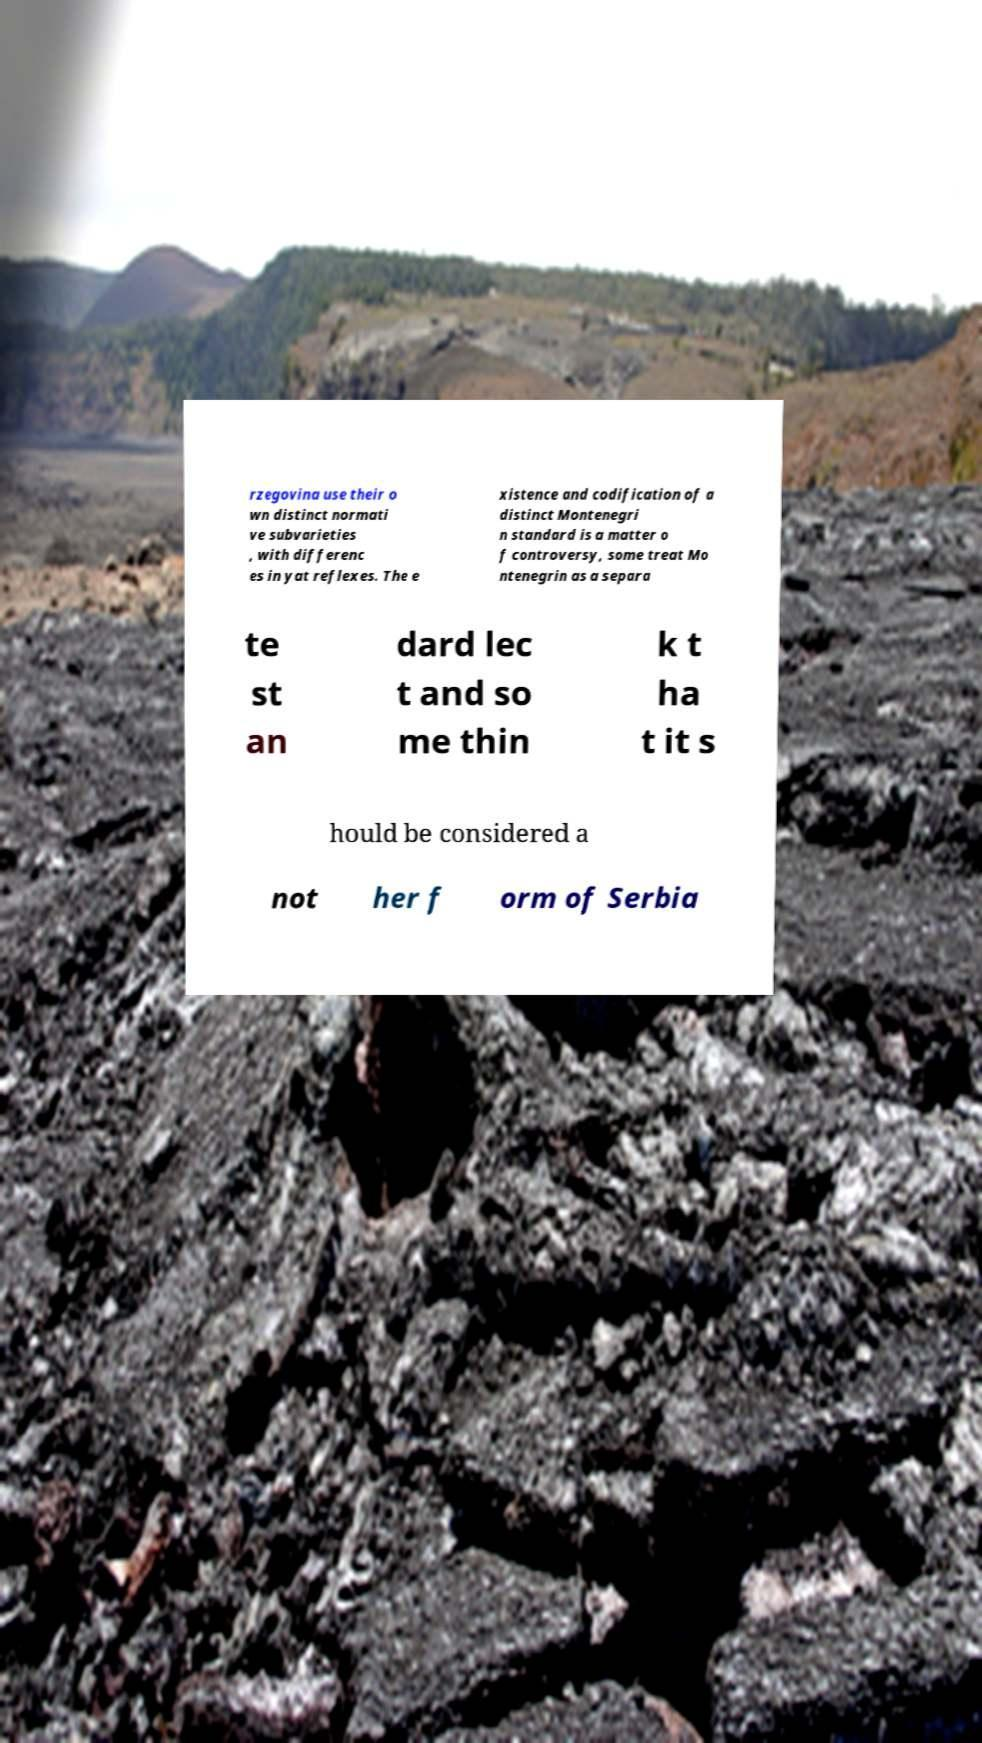Can you read and provide the text displayed in the image?This photo seems to have some interesting text. Can you extract and type it out for me? rzegovina use their o wn distinct normati ve subvarieties , with differenc es in yat reflexes. The e xistence and codification of a distinct Montenegri n standard is a matter o f controversy, some treat Mo ntenegrin as a separa te st an dard lec t and so me thin k t ha t it s hould be considered a not her f orm of Serbia 